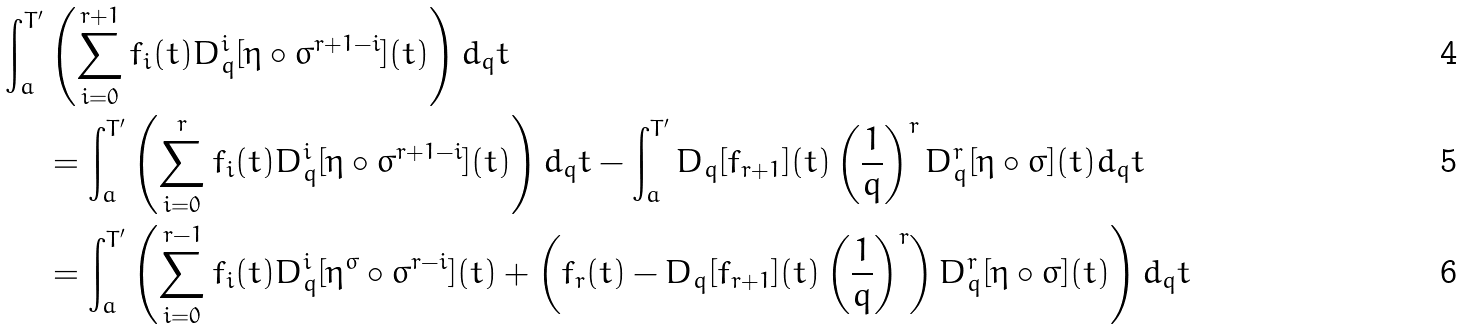Convert formula to latex. <formula><loc_0><loc_0><loc_500><loc_500>\int _ { a } ^ { T ^ { \prime } } & \left ( \sum _ { i = 0 } ^ { r + 1 } f _ { i } ( t ) D _ { q } ^ { i } [ \eta \circ \sigma ^ { r + 1 - i } ] ( t ) \right ) d _ { q } t \\ & = \int _ { a } ^ { T ^ { \prime } } \left ( \sum _ { i = 0 } ^ { r } f _ { i } ( t ) D _ { q } ^ { i } [ \eta \circ \sigma ^ { r + 1 - i } ] ( t ) \right ) d _ { q } t - \int _ { a } ^ { T ^ { \prime } } D _ { q } [ f _ { r + 1 } ] ( t ) \left ( \frac { 1 } { q } \right ) ^ { r } D _ { q } ^ { r } [ \eta \circ \sigma ] ( t ) d _ { q } t \\ & = \int _ { a } ^ { T ^ { \prime } } \left ( \sum _ { i = 0 } ^ { r - 1 } f _ { i } ( t ) D _ { q } ^ { i } [ \eta ^ { \sigma } \circ \sigma ^ { r - i } ] ( t ) + \left ( f _ { r } ( t ) - D _ { q } [ f _ { r + 1 } ] ( t ) \left ( \frac { 1 } { q } \right ) ^ { r } \right ) D _ { q } ^ { r } [ \eta \circ \sigma ] ( t ) \right ) d _ { q } t</formula> 